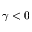<formula> <loc_0><loc_0><loc_500><loc_500>\gamma < 0</formula> 